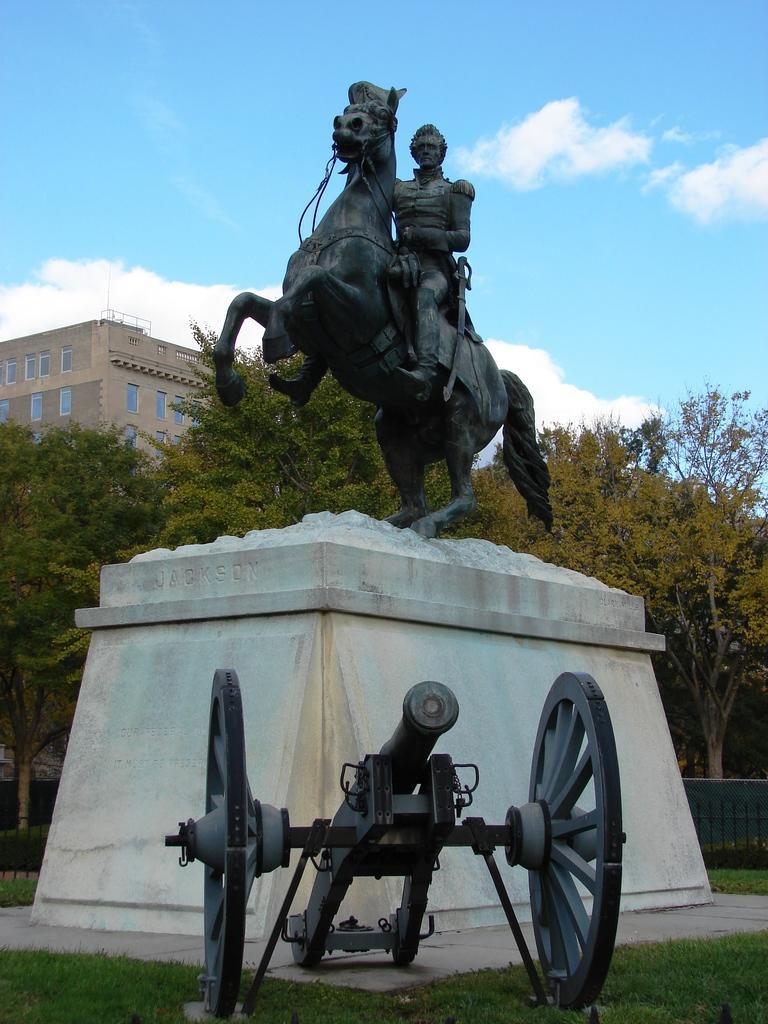Describe this image in one or two sentences. In this image we can see a statue of a person and the horse. Behind the statue we can see a fencing, building and a group of trees. At the bottom we can see the grass and the cannon. At the top we can see the sky. 